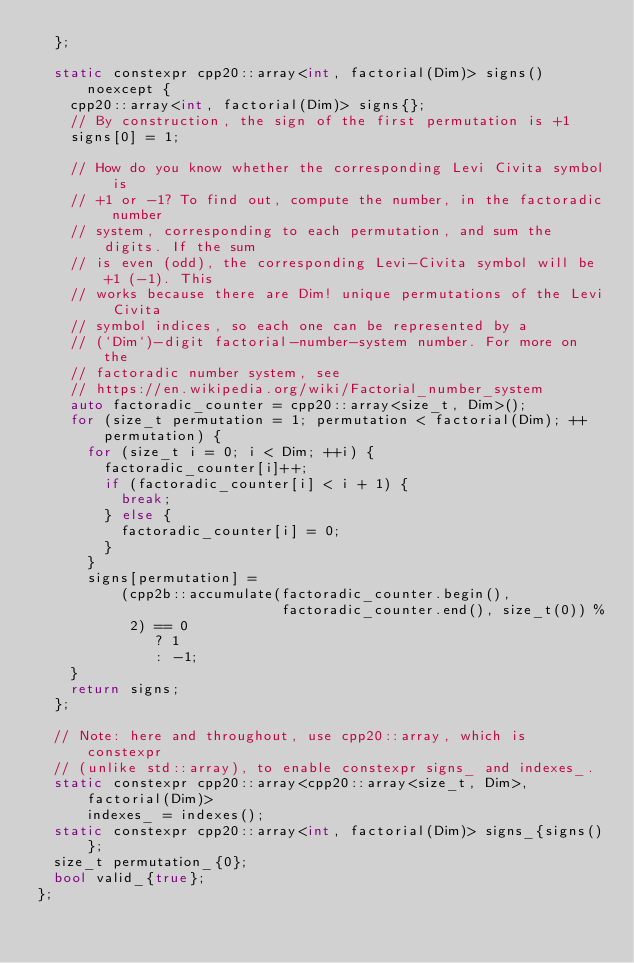<code> <loc_0><loc_0><loc_500><loc_500><_C++_>  };

  static constexpr cpp20::array<int, factorial(Dim)> signs() noexcept {
    cpp20::array<int, factorial(Dim)> signs{};
    // By construction, the sign of the first permutation is +1
    signs[0] = 1;

    // How do you know whether the corresponding Levi Civita symbol is
    // +1 or -1? To find out, compute the number, in the factoradic number
    // system, corresponding to each permutation, and sum the digits. If the sum
    // is even (odd), the corresponding Levi-Civita symbol will be +1 (-1). This
    // works because there are Dim! unique permutations of the Levi Civita
    // symbol indices, so each one can be represented by a
    // (`Dim`)-digit factorial-number-system number. For more on the
    // factoradic number system, see
    // https://en.wikipedia.org/wiki/Factorial_number_system
    auto factoradic_counter = cpp20::array<size_t, Dim>();
    for (size_t permutation = 1; permutation < factorial(Dim); ++permutation) {
      for (size_t i = 0; i < Dim; ++i) {
        factoradic_counter[i]++;
        if (factoradic_counter[i] < i + 1) {
          break;
        } else {
          factoradic_counter[i] = 0;
        }
      }
      signs[permutation] =
          (cpp2b::accumulate(factoradic_counter.begin(),
                             factoradic_counter.end(), size_t(0)) %
           2) == 0
              ? 1
              : -1;
    }
    return signs;
  };

  // Note: here and throughout, use cpp20::array, which is constexpr
  // (unlike std::array), to enable constexpr signs_ and indexes_.
  static constexpr cpp20::array<cpp20::array<size_t, Dim>, factorial(Dim)>
      indexes_ = indexes();
  static constexpr cpp20::array<int, factorial(Dim)> signs_{signs()};
  size_t permutation_{0};
  bool valid_{true};
};
</code> 